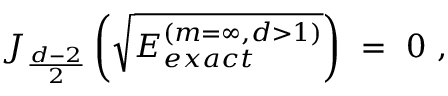Convert formula to latex. <formula><loc_0><loc_0><loc_500><loc_500>J _ { \frac { d - 2 } { 2 } } \left ( \sqrt { E _ { e x a c t } ^ { ( m = \infty , d > 1 ) } } \right ) \ = \ 0 \ ,</formula> 